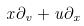<formula> <loc_0><loc_0><loc_500><loc_500>x \partial _ { v } + u \partial _ { x }</formula> 